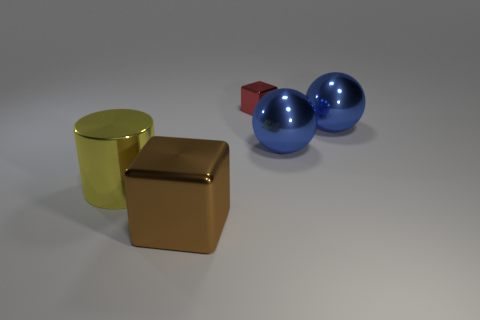Add 5 large yellow cylinders. How many objects exist? 10 Subtract all cubes. How many objects are left? 3 Add 4 big yellow shiny things. How many big yellow shiny things exist? 5 Subtract 0 red balls. How many objects are left? 5 Subtract all large green matte cylinders. Subtract all small blocks. How many objects are left? 4 Add 4 big cylinders. How many big cylinders are left? 5 